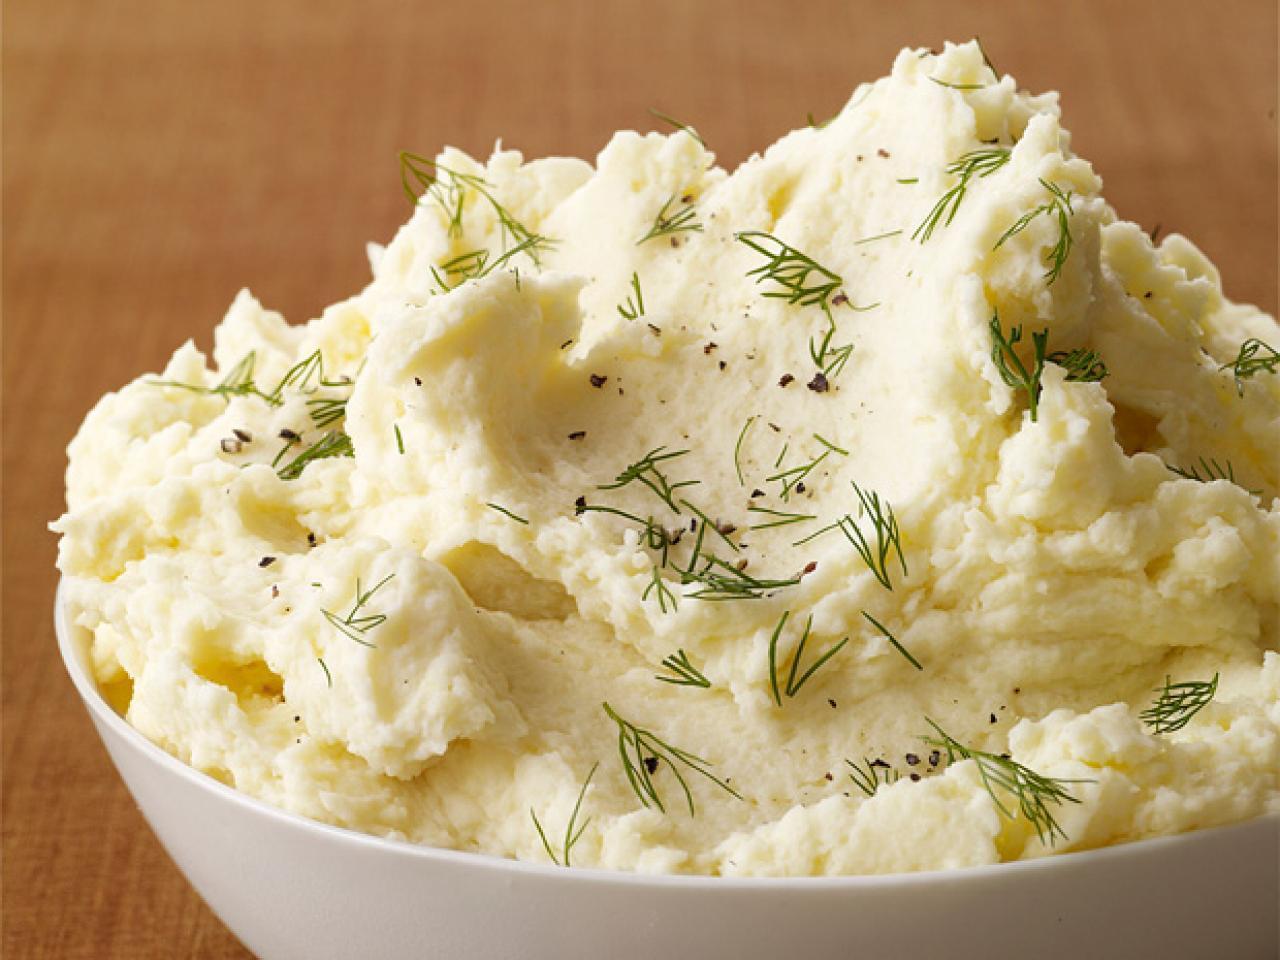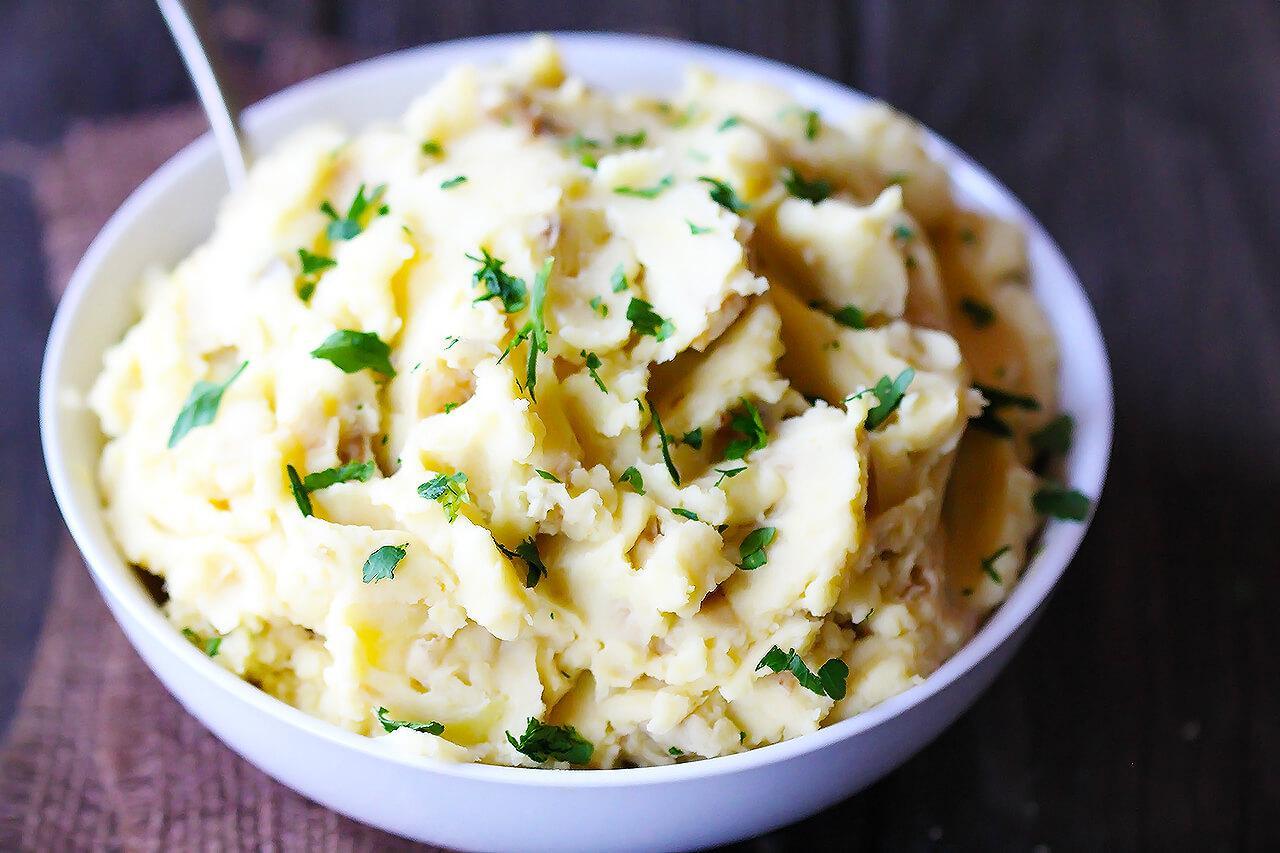The first image is the image on the left, the second image is the image on the right. Assess this claim about the two images: "One image has an eating utensil.". Correct or not? Answer yes or no. Yes. 